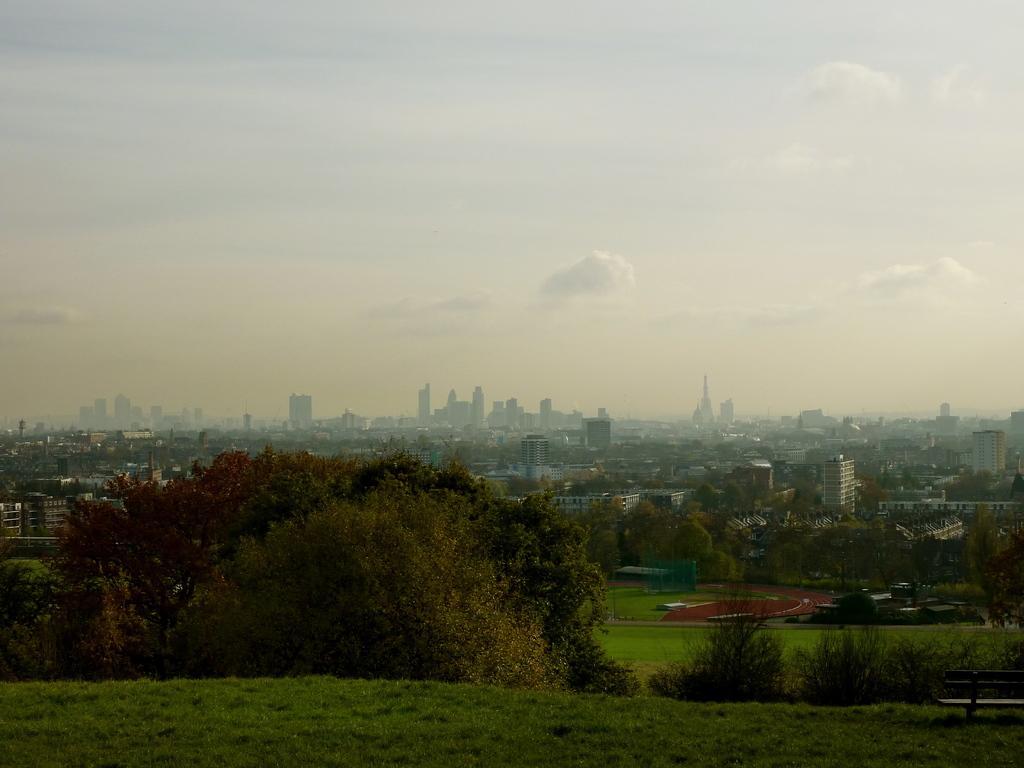Can you describe this image briefly? In this image I can see many trees on the ground. To the right I can see the bench. In the background there are many buildings. I can also see the clouds and the sky in the back. 